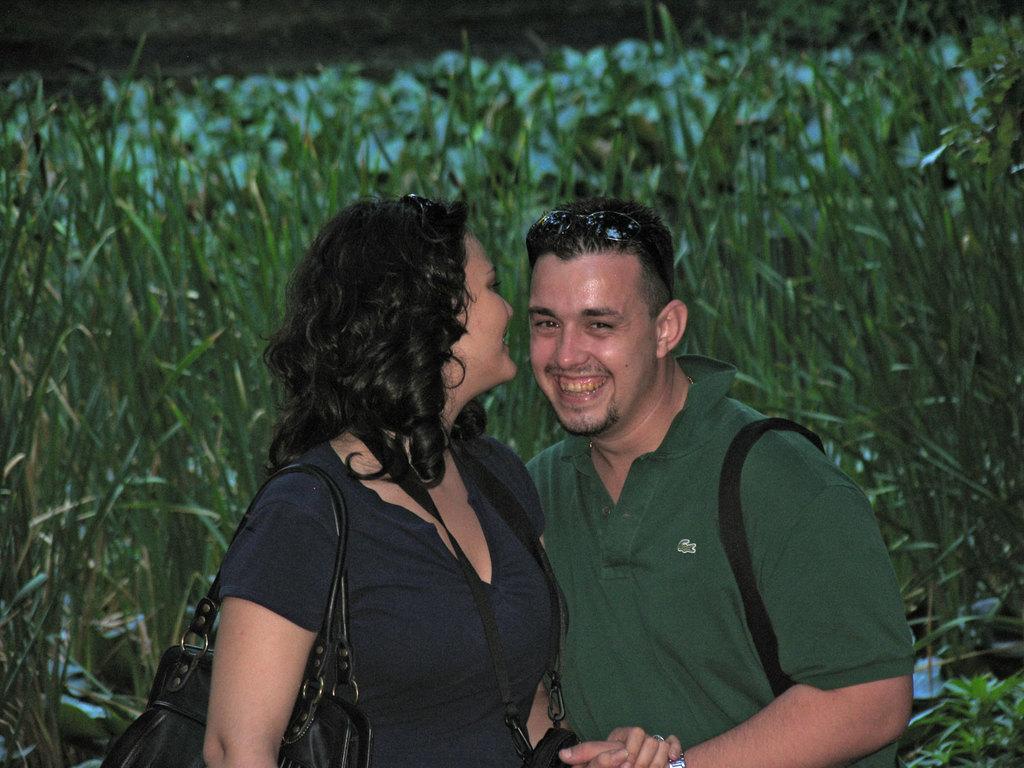Please provide a concise description of this image. In this image we can see a man and a woman. They are smiling. In the background we can see plants and grass. 